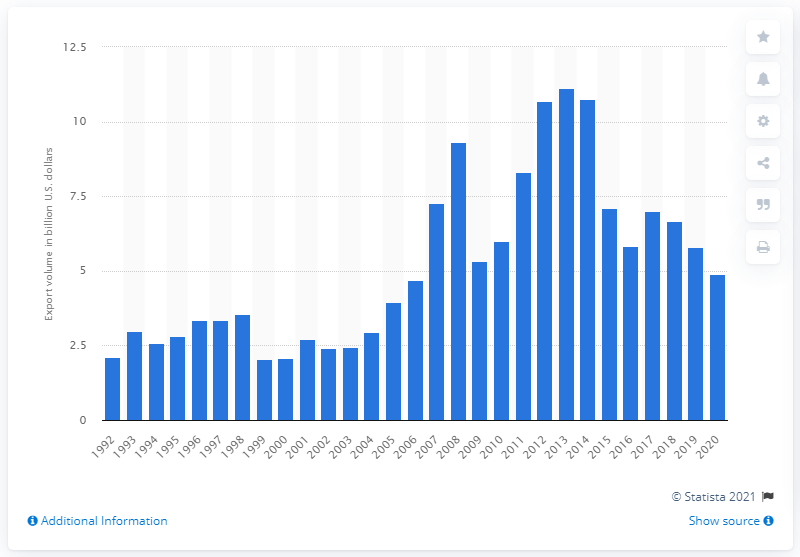Give some essential details in this illustration. In 2020, the value of U.S. exports to Russia was $4.88 billion in dollars. 